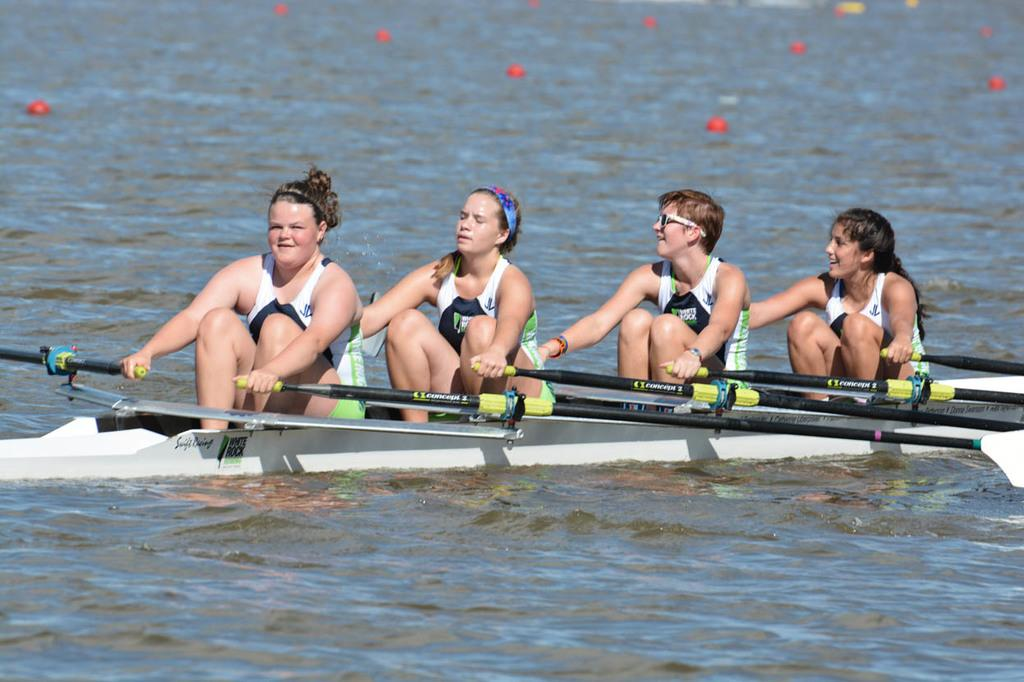How many people are in the image? There are 3 women and a man in the image, making a total of 4 people. What are they doing in the image? They are on a boat and each of them is holding a paddle. What can be seen in the background of the image? There is water visible in the image. What color are the objects floating on the water? The objects on the water are red-colored. What type of twig is being used as a guide for the boat in the image? There is no twig being used as a guide for the boat in the image. The people are using paddles to navigate the boat. 